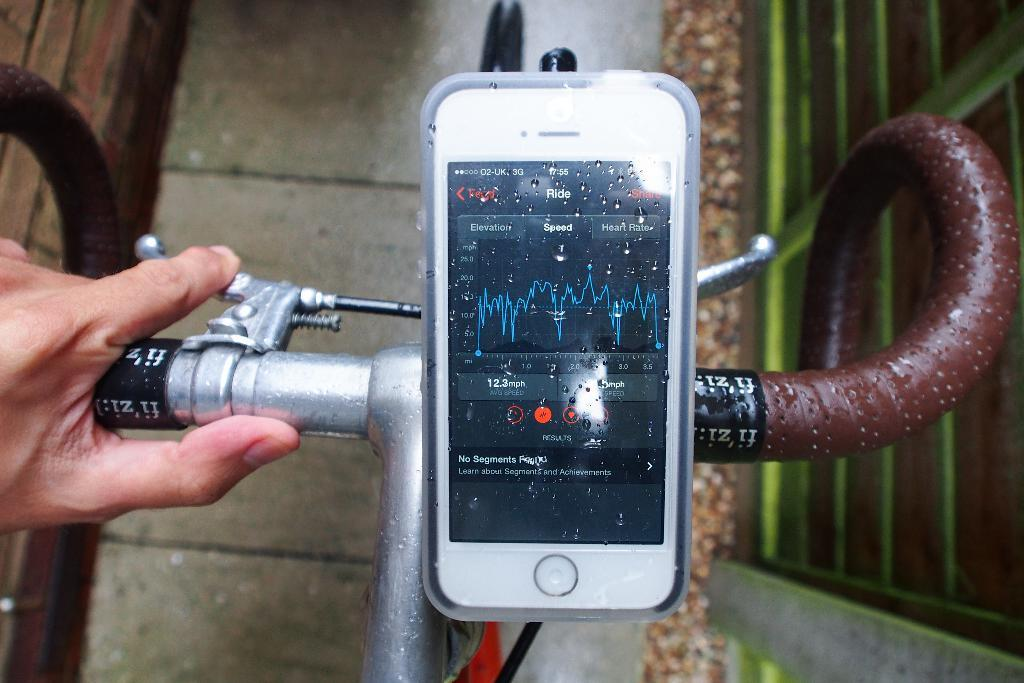Provide a one-sentence caption for the provided image. A phone with the word Ride put on it. 